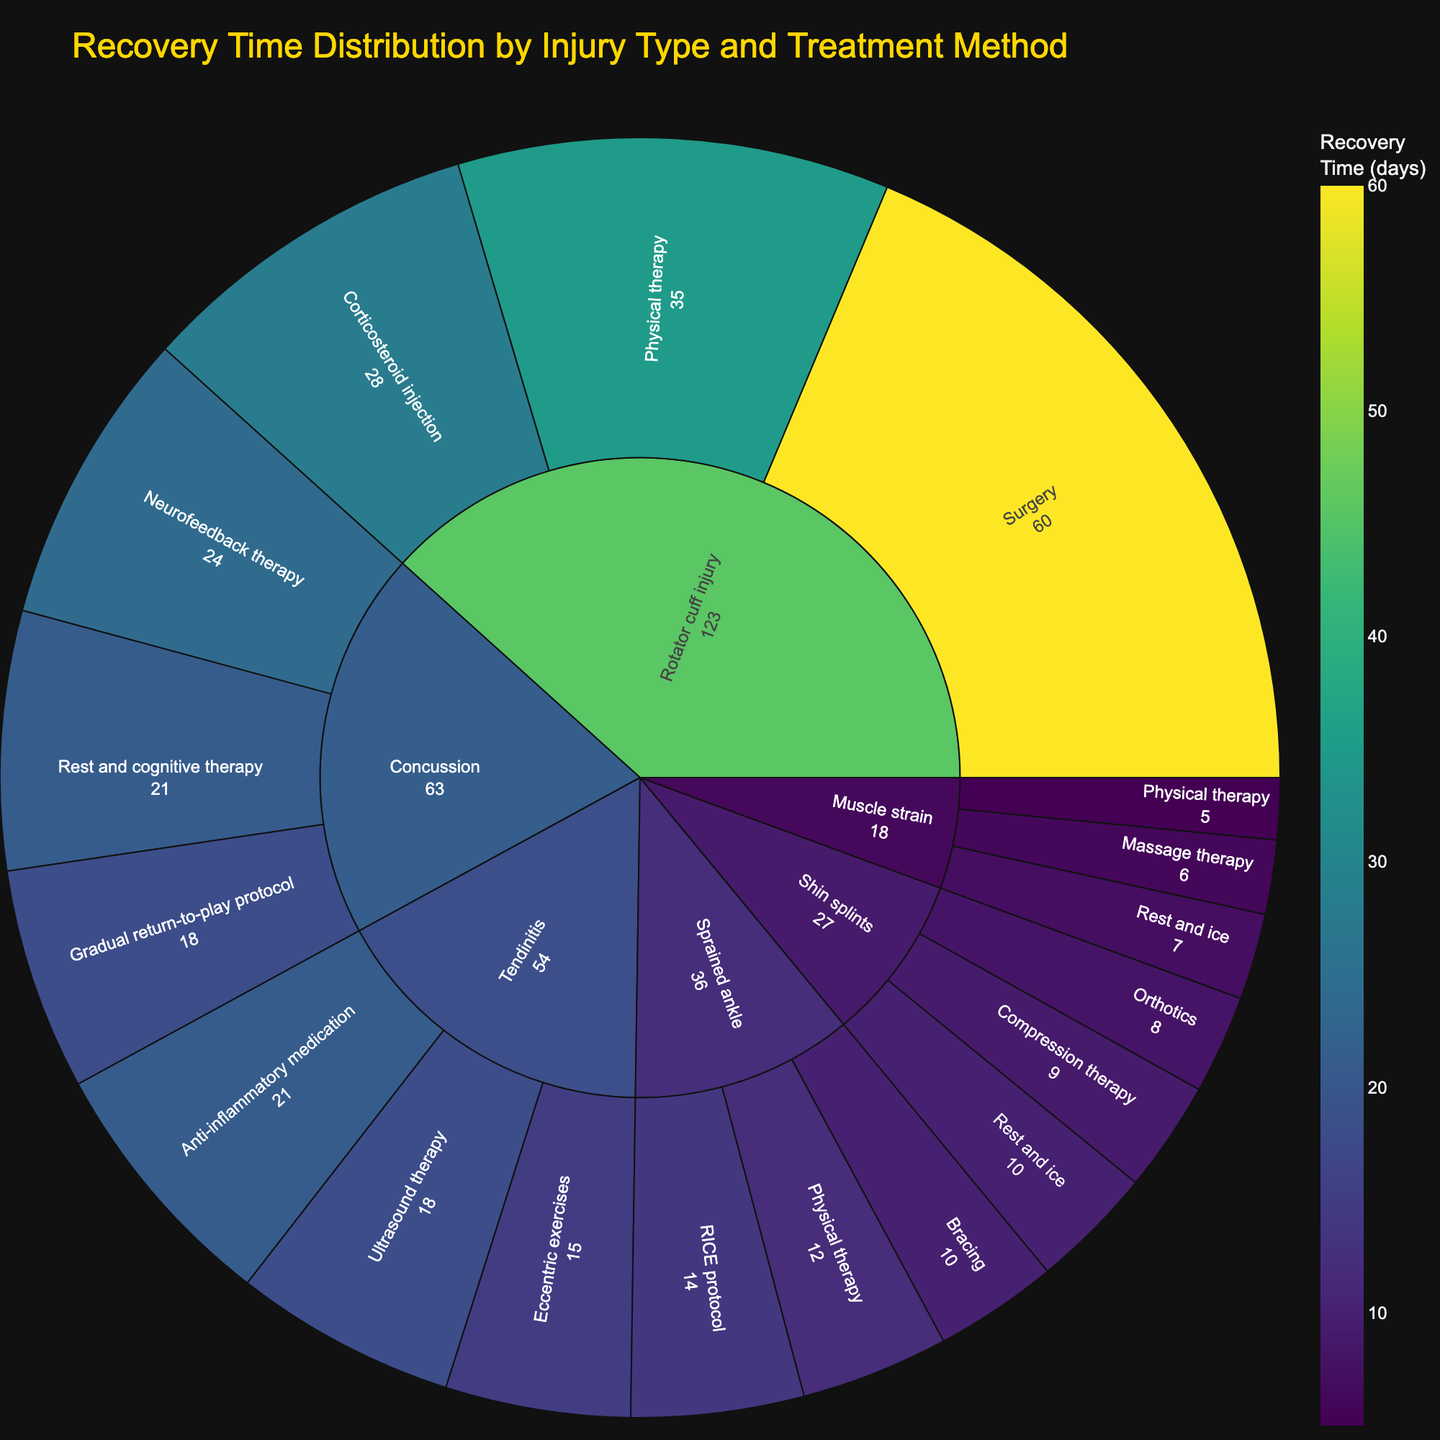what is the title of the sunburst plot? The title is usually located at the top of the plot and provides a summary of what the plot is about. Here, it's clearly indicated as "Recovery Time Distribution by Injury Type and Treatment Method".
Answer: Recovery Time Distribution by Injury Type and Treatment Method Which treatment method for a muscle strain has the shortest recovery time? To determine this, look at the sub-segments under "Muscle strain" and find the one with the smallest recovery time value. Physical therapy has a recovery time of 5 days, which is the shortest.
Answer: Physical therapy How many injury types are displayed in the sunburst plot? Count the number of distinct segments at the first hierarchical level of the sunburst plot. There are six types: Muscle strain, Sprained ankle, Tendinitis, Shin splints, Rotator cuff injury, and Concussion.
Answer: 6 Which treatment method for tendinitis has the longest recovery time? Look at the sub-segments under "Tendinitis" and find the one with the largest recovery time. Anti-inflammatory medication has a recovery time of 21 days, which is the longest.
Answer: Anti-inflammatory medication What is the total recovery time for all treatment methods for a sprained ankle? Sum the recovery times of all sub-segments under "Sprained ankle". The values are 14 (RICE protocol) + 10 (Bracing) + 12 (Physical therapy) which gives a total of 36 days.
Answer: 36 days Which injury type has the highest recovery time for its treatment methods? Look at the outer segments of the sunburst plot and identify the one with the highest value. Surgery for a Rotator cuff injury has a recovery time of 60 days.
Answer: Rotator cuff injury (Surgery) What is the average recovery time for the treatment methods under shin splints? Sum the recovery times under "Shin splints" and then divide by the number of treatment methods. (10 + 8 + 9) / 3 = 27 / 3 = 9 days.
Answer: 9 days Compare the recovery times of the treatments for a concussion and identify which is the most effective. Assess the sub-segments under "Concussion" for their recovery times. Gradual return-to-play protocol has a recovery time of 18 days, which is the shortest and thus the most effective.
Answer: Gradual return-to-play protocol What is the total recovery time for all the injury types? Sum the values of all the sub-segments in the sunburst plot. The sum of recovery times is 7 + 5 + 6 + 14 + 10 + 12 + 21 + 18 + 15 + 10 + 8 + 9 + 28 + 35 + 60 + 21 + 18 + 24 = 331 days.
Answer: 331 days Which treatment method has the highest average recovery time across all injury types? Calculate the average recovery time for each treatment method and compare. For this, sum the recovery times and divide by the number of occurrences per treatment method. Surgery for Rotator cuff injury has 60/1 = 60 days, which is the highest.
Answer: Surgery 